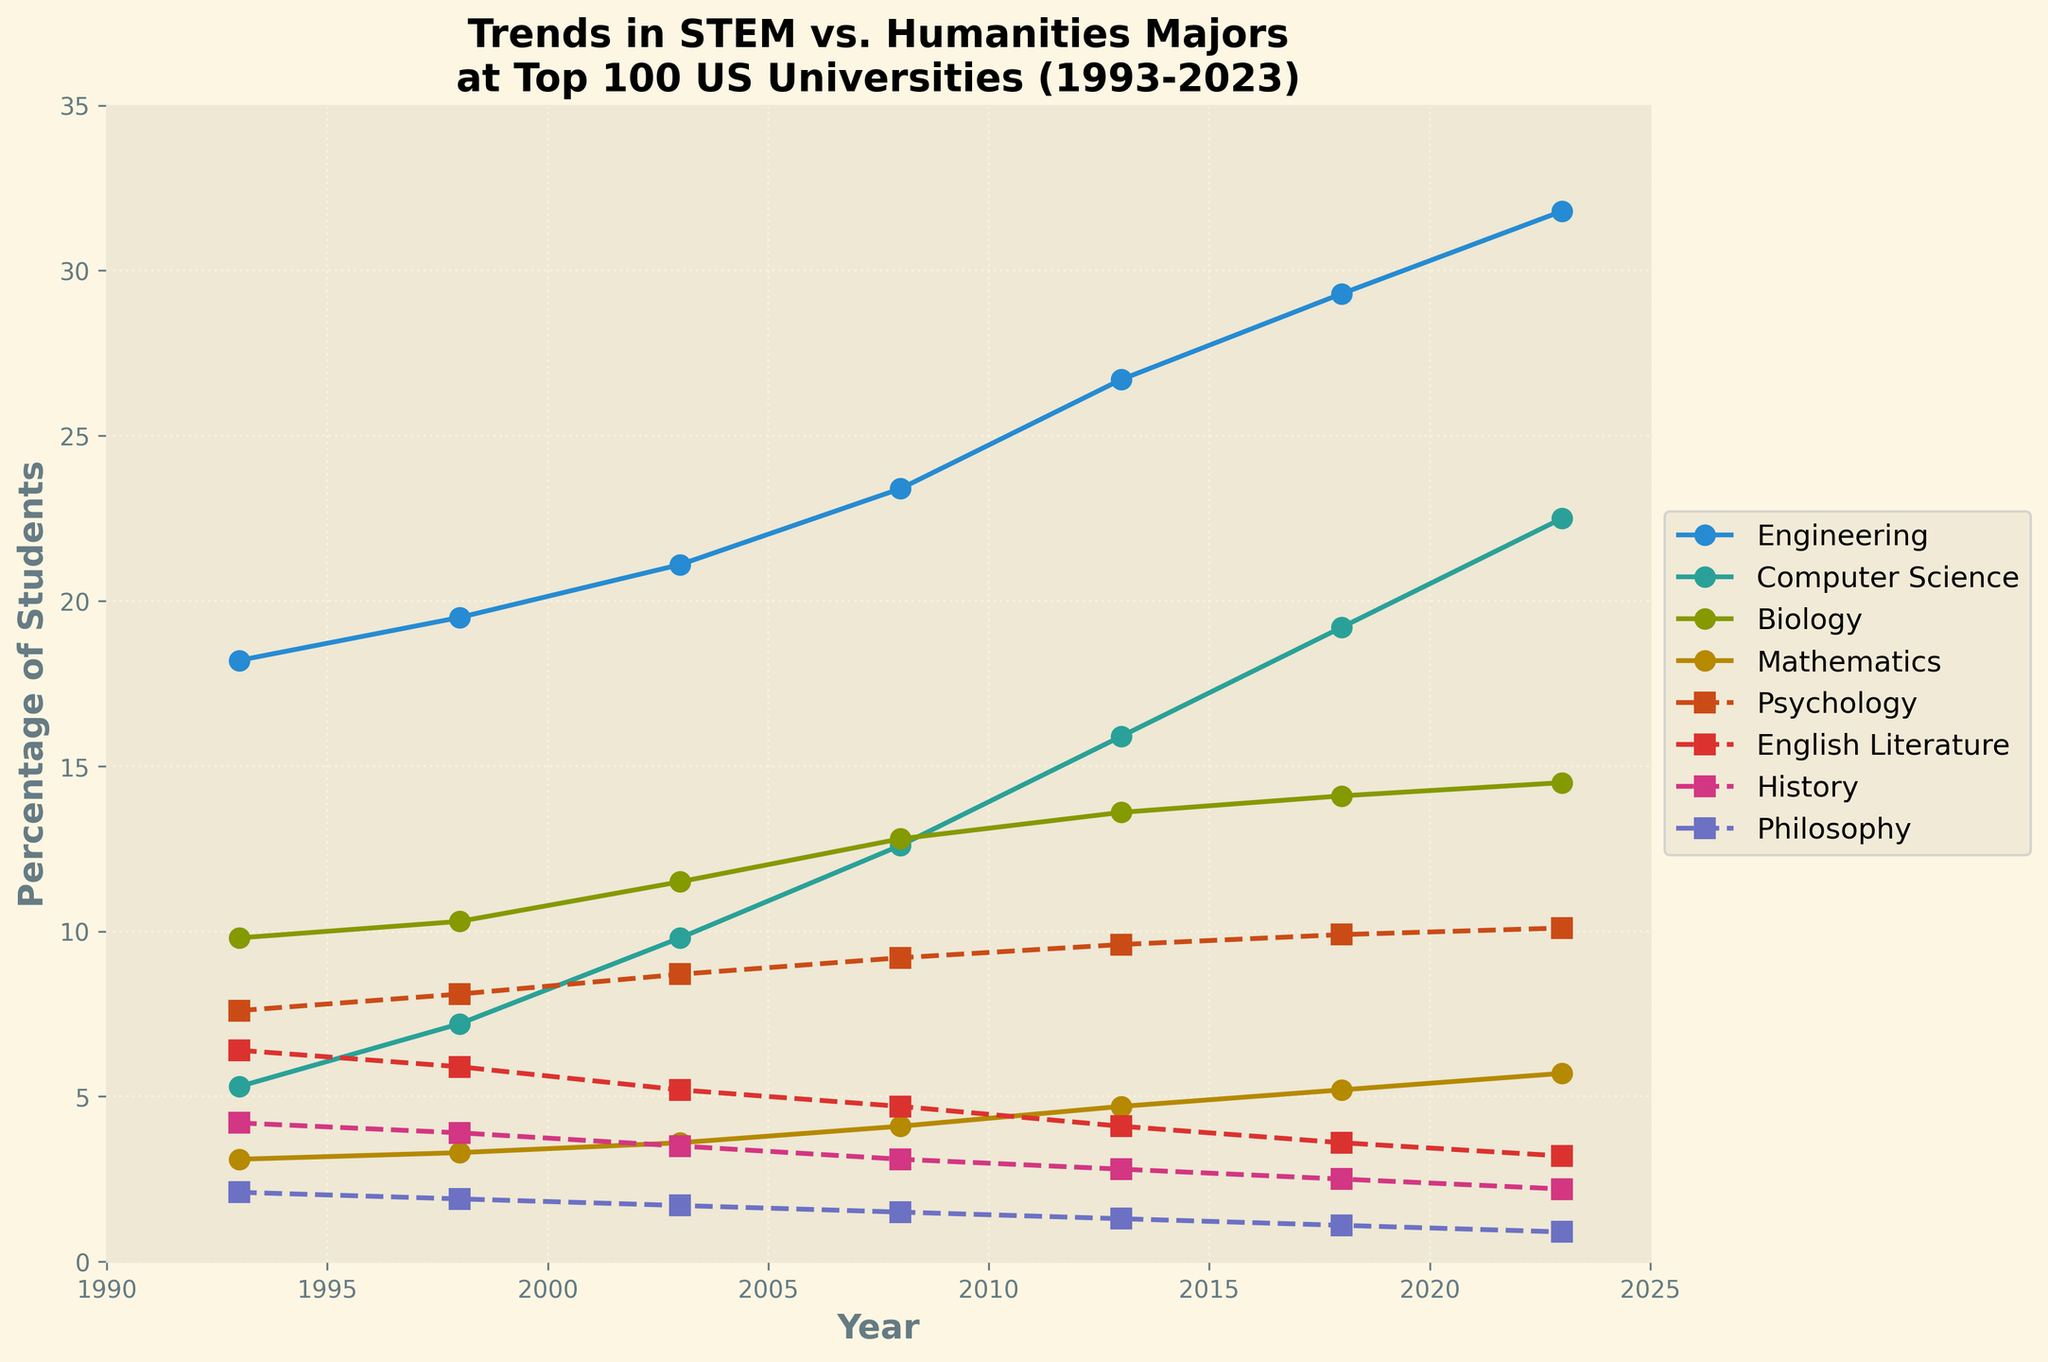Which major has the highest percentage of students in 2023? Looking at the data points for the year 2023, Engineering shows the highest value of 31.8%.
Answer: Engineering What is the percentage point difference between Computer Science and Psychology in 2023? In 2023, the percentage for Computer Science is 22.5% and for Psychology is 10.1%. The difference is 22.5 - 10.1 = 12.4 percentage points.
Answer: 12.4 How has the percentage of students majoring in Philosophy changed from 1993 to 2023? In 1993, the percentage for Philosophy is 2.1%, and it decreases to 0.9% in 2023. The change is 0.9 - 2.1 = -1.2 percentage points.
Answer: -1.2 Which STEM field saw the greatest increase in percentage from 1993 to 2023? Comparing the data for STEM fields (Engineering, Computer Science, Biology, Mathematics) from 1993 to 2023, Computer Science increased from 5.3% to 22.5%, which is an increase of 22.5 - 5.3 = 17.2 percentage points, the highest among the STEM fields.
Answer: Computer Science What is the average percentage of students majoring in English Literature over the 30-year period? Adding the percentages of English Literature for each year (6.4 + 5.9 + 5.2 + 4.7 + 4.1 + 3.6 + 3.2) and dividing by 7 gives the average: (6.4 + 5.9 + 5.2 + 4.7 + 4.1 + 3.6 + 3.2) / 7 ≈ 4.73%.
Answer: 4.73% Which major shows a consistently decreasing trend over the 30 years? Observing the data for each major, History shows a consistent decrease: 4.2% in 1993, 3.9% in 1998, 3.5% in 2003, 3.1% in 2008, 2.8% in 2013, 2.5% in 2018, and 2.2% in 2023.
Answer: History Is the percentage of Mathematics majors higher or lower than Biology majors in 2023? By comparing the data points for 2023, Mathematics has 5.7% and Biology has 14.5%, so Mathematics is lower than Biology.
Answer: Lower In which year did Computer Science surpass Biology in terms of the percentage of students? By analyzing the trend lines, in 2013, Computer Science (15.9%) surpasses Biology (13.6%).
Answer: 2013 What is the combined percentage of students majoring in STEM fields in 2023? Adding the percentages for STEM fields (Engineering, Computer Science, Biology, Mathematics) in 2023: 31.8 + 22.5 + 14.5 + 5.7 = 74.5%.
Answer: 74.5 Which Humanities major has the highest percentage decline from 1993 to 2023? Comparing the percentages between 1993 and 2023 for Humanities majors, English Literature declined from 6.4% to 3.2%, which is a decline of 6.4 - 3.2 = 3.2 percentage points, the highest among the Humanities majors.
Answer: English Literature 